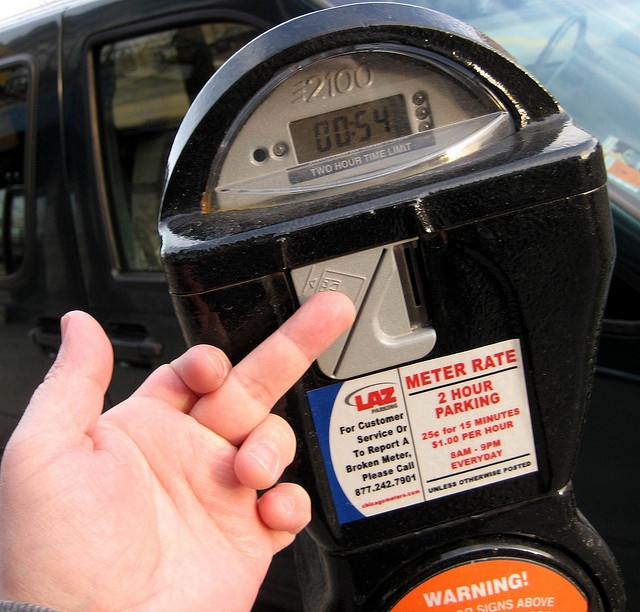Describe the objects in this image and their specific colors. I can see parking meter in black, white, gray, darkgray, and lightgray tones, people in white, lightpink, pink, and salmon tones, and car in white, black, darkgreen, and gray tones in this image. 